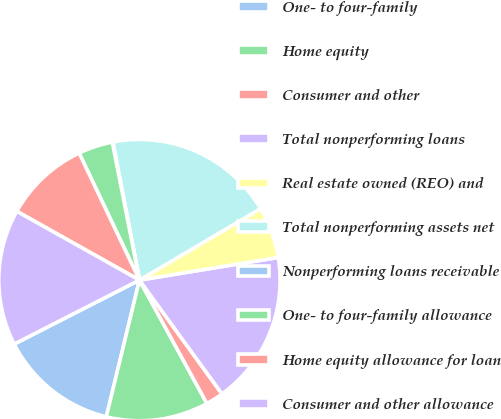Convert chart. <chart><loc_0><loc_0><loc_500><loc_500><pie_chart><fcel>One- to four-family<fcel>Home equity<fcel>Consumer and other<fcel>Total nonperforming loans<fcel>Real estate owned (REO) and<fcel>Total nonperforming assets net<fcel>Nonperforming loans receivable<fcel>One- to four-family allowance<fcel>Home equity allowance for loan<fcel>Consumer and other allowance<nl><fcel>13.7%<fcel>11.75%<fcel>2.02%<fcel>17.59%<fcel>5.91%<fcel>19.54%<fcel>0.07%<fcel>3.96%<fcel>9.81%<fcel>15.65%<nl></chart> 